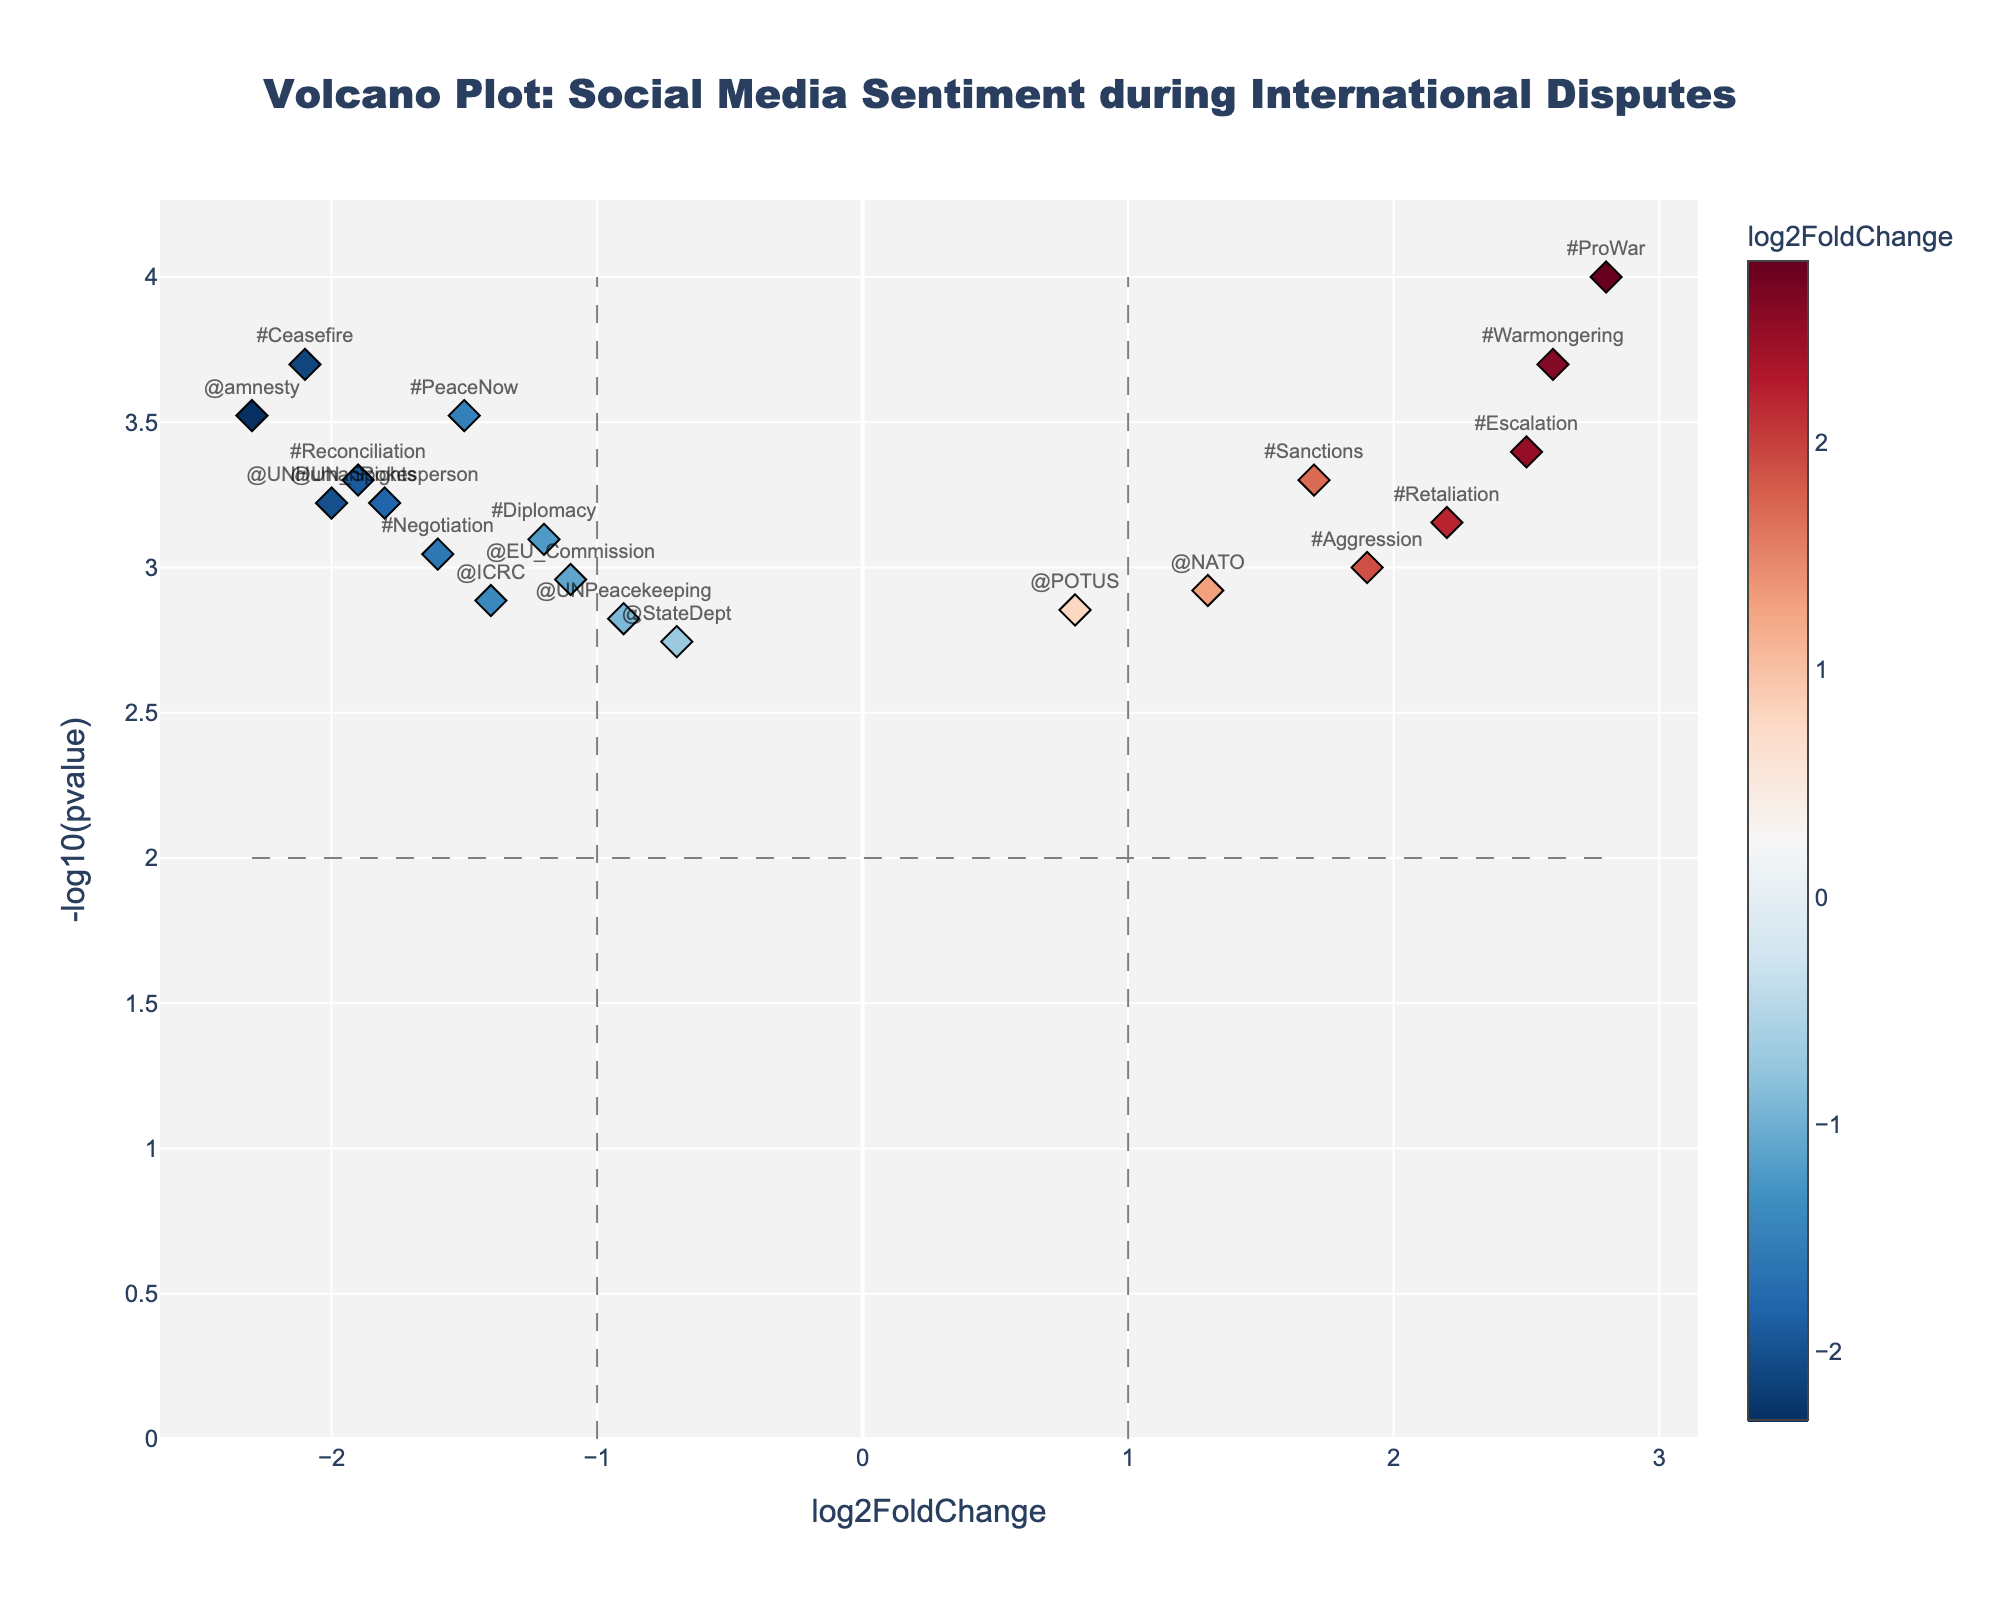What is the title of the figure? The title of the figure is clearly written at the top, centered in large text.
Answer: Volcano Plot: Social Media Sentiment during International Disputes How many points have a log2FoldChange greater than 2? Points with a log2FoldChange greater than 2 are to the right of the vertical line at x=1 and above a certain value.
Answer: 3 Which term has the most significant p-value? The most significant p-value corresponds to the highest -log10(pvalue) in the y-axis. Identify the term associated with this point.
Answer: #ProWar Are there more terms with positive or negative log2FoldChange? Count the number of points to the left of the vertical line at x=0 for negative log2FoldChange and count the points to the right for positive log2FoldChange. Compare these counts.
Answer: More terms with negative log2FoldChange Which term shows a log2FoldChange close to zero but is still statistically significant? Points near the x=0 line but above the horizontal significance threshold give us terms with log2FoldChange close to zero but still significant.
Answer: @POTUS Among the points with positive log2FoldChange, which has the second highest -log10(pvalue)? Identify all points with positive log2FoldChange, then find the one with the second highest value on the y-axis.
Answer: #Escalation Which term has the highest -log10(pvalue) among those with a negative log2FoldChange less than -1? Look at the points to the left of x=-1 and determine which has the highest y-axis value.
Answer: @amnesty Which term shows a log2FoldChange of less than -1.5 and is also labeled on the figure? Identify points to the left of x=-1.5 that have label annotations.
Answer: #Ceasefire What is the log2FoldChange for the term @ICRC? Locate the (@ICRC) point on the plot and read the x-axis value corresponding to it.
Answer: -1.4 How many terms fall within the boundaries defined by -1 < log2FoldChange < 1 and are statistically significant? Count the points that fall between -1 and 1 on the x-axis but above the horizontal significance threshold line.
Answer: 5 